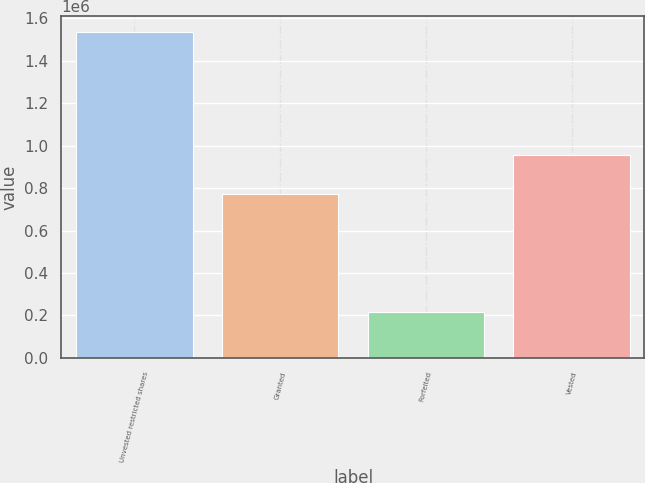<chart> <loc_0><loc_0><loc_500><loc_500><bar_chart><fcel>Unvested restricted shares<fcel>Granted<fcel>Forfeited<fcel>Vested<nl><fcel>1.53322e+06<fcel>769858<fcel>218505<fcel>955195<nl></chart> 